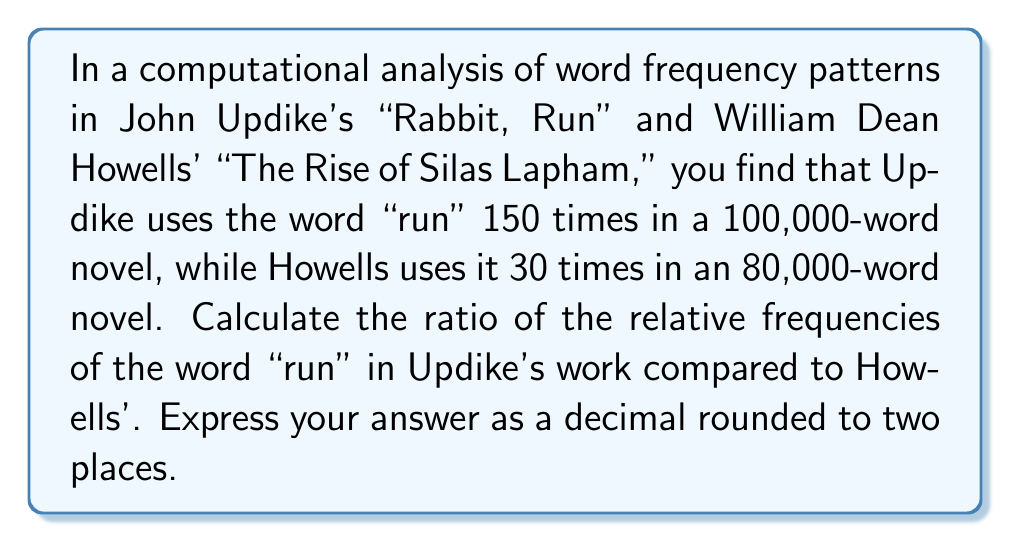Can you solve this math problem? To solve this problem, we need to follow these steps:

1. Calculate the relative frequency of "run" in Updike's work:
   $$f_{Updike} = \frac{\text{Number of occurrences}}{\text{Total words}} = \frac{150}{100,000} = 0.0015$$

2. Calculate the relative frequency of "run" in Howells' work:
   $$f_{Howells} = \frac{\text{Number of occurrences}}{\text{Total words}} = \frac{30}{80,000} = 0.000375$$

3. Calculate the ratio of these relative frequencies:
   $$\text{Ratio} = \frac{f_{Updike}}{f_{Howells}} = \frac{0.0015}{0.000375} = 4$$

Therefore, the relative frequency of "run" in Updike's work is 4 times that in Howells' work.
Answer: 4.00 